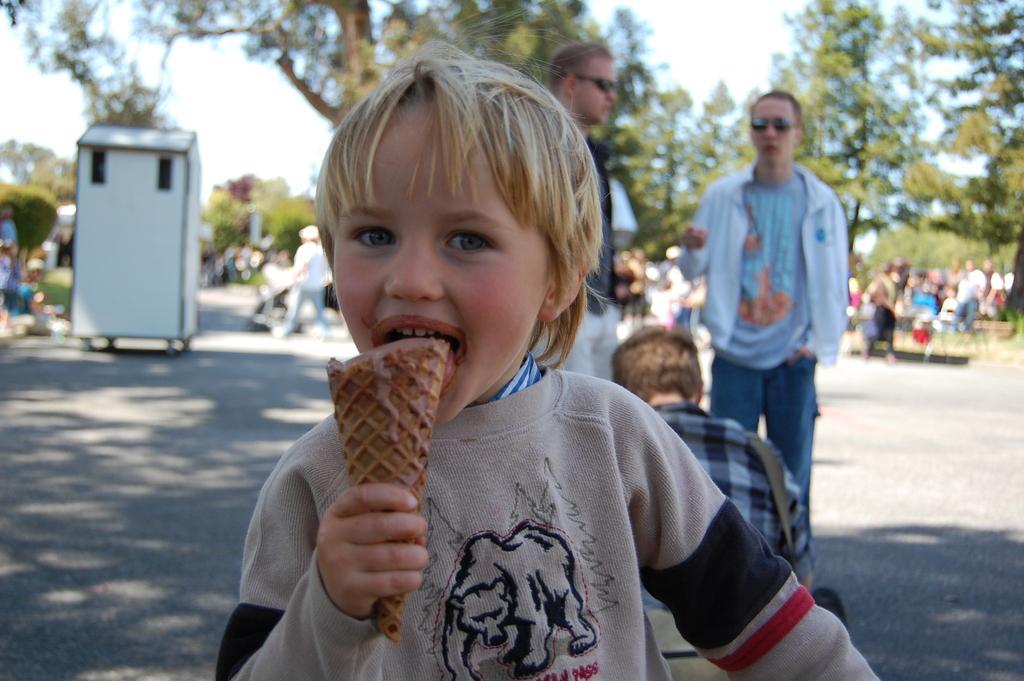In one or two sentences, can you explain what this image depicts? There is a child eating an ice cream. In the back there are many people. Also there are trees. There are two persons wearing goggles. On the left side There is a white box. In the background there is sky. 